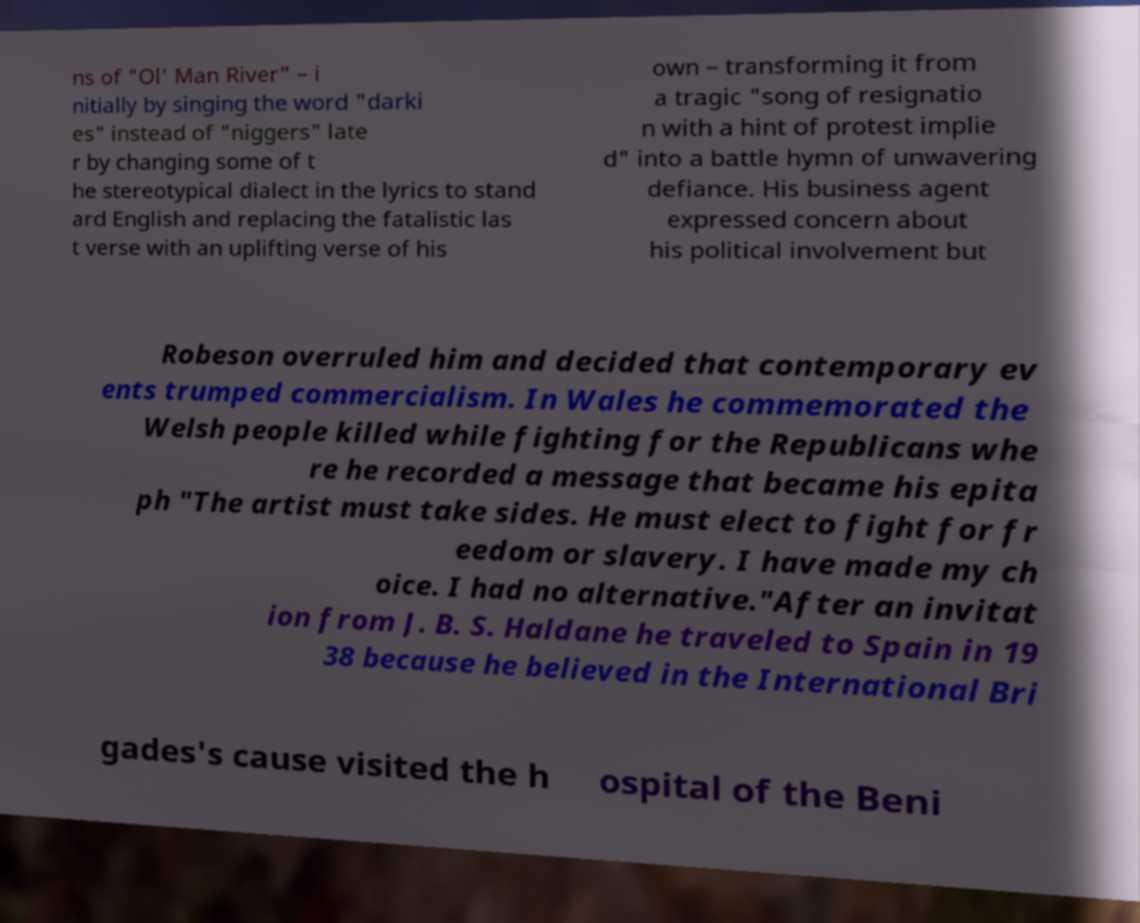I need the written content from this picture converted into text. Can you do that? ns of "Ol' Man River" – i nitially by singing the word "darki es" instead of "niggers" late r by changing some of t he stereotypical dialect in the lyrics to stand ard English and replacing the fatalistic las t verse with an uplifting verse of his own – transforming it from a tragic "song of resignatio n with a hint of protest implie d" into a battle hymn of unwavering defiance. His business agent expressed concern about his political involvement but Robeson overruled him and decided that contemporary ev ents trumped commercialism. In Wales he commemorated the Welsh people killed while fighting for the Republicans whe re he recorded a message that became his epita ph "The artist must take sides. He must elect to fight for fr eedom or slavery. I have made my ch oice. I had no alternative."After an invitat ion from J. B. S. Haldane he traveled to Spain in 19 38 because he believed in the International Bri gades's cause visited the h ospital of the Beni 